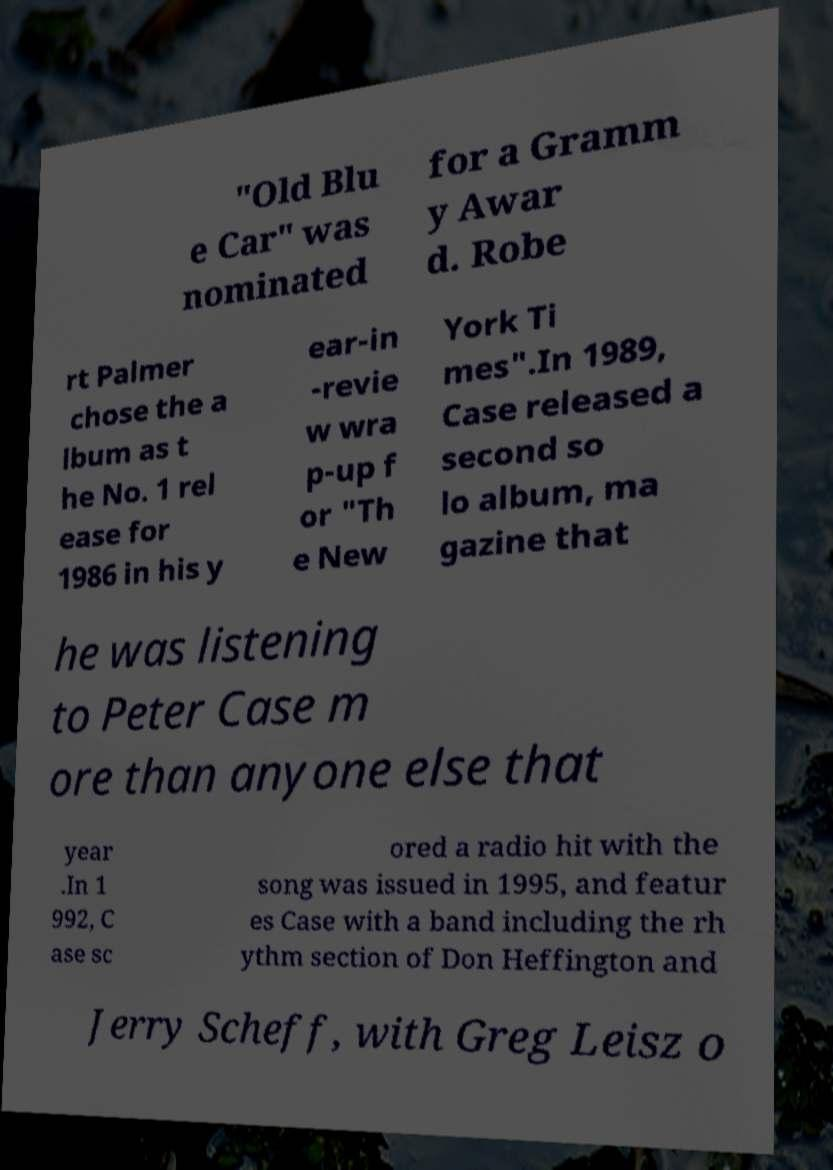I need the written content from this picture converted into text. Can you do that? "Old Blu e Car" was nominated for a Gramm y Awar d. Robe rt Palmer chose the a lbum as t he No. 1 rel ease for 1986 in his y ear-in -revie w wra p-up f or "Th e New York Ti mes".In 1989, Case released a second so lo album, ma gazine that he was listening to Peter Case m ore than anyone else that year .In 1 992, C ase sc ored a radio hit with the song was issued in 1995, and featur es Case with a band including the rh ythm section of Don Heffington and Jerry Scheff, with Greg Leisz o 